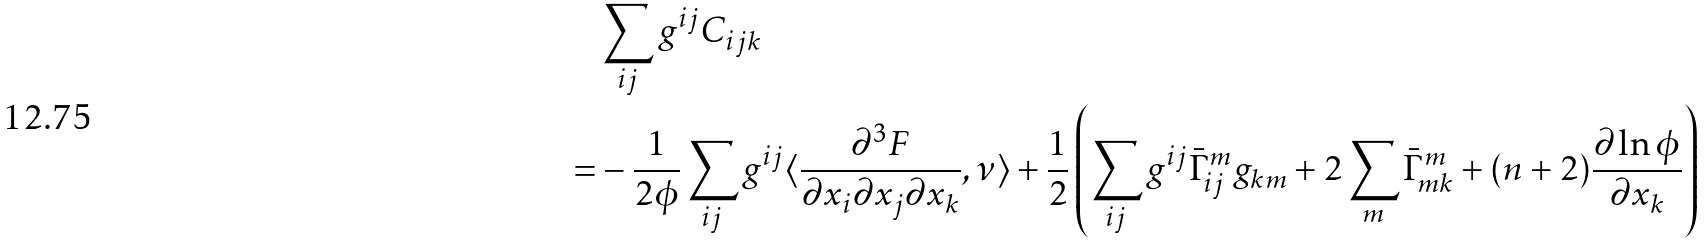Convert formula to latex. <formula><loc_0><loc_0><loc_500><loc_500>& \sum _ { i j } g ^ { i j } C _ { i j k } \\ = & - \frac { 1 } { 2 \phi } \sum _ { i j } g ^ { i j } \langle \frac { \partial ^ { 3 } F } { \partial x _ { i } \partial x _ { j } \partial x _ { k } } , \nu \rangle + \frac { 1 } { 2 } \left ( \sum _ { i j } g ^ { i j } \bar { \Gamma } ^ { m } _ { i j } g _ { k m } + 2 \sum _ { m } \bar { \Gamma } ^ { m } _ { m k } + ( n + 2 ) \frac { \partial \ln \phi } { \partial x _ { k } } \right ) \\</formula> 